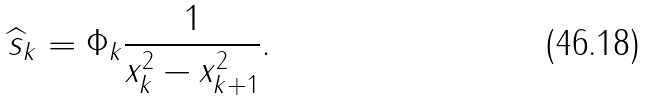<formula> <loc_0><loc_0><loc_500><loc_500>\widehat { s } _ { k } = \Phi _ { k } \frac { 1 } { x _ { k } ^ { 2 } - x ^ { 2 } _ { k + 1 } } .</formula> 